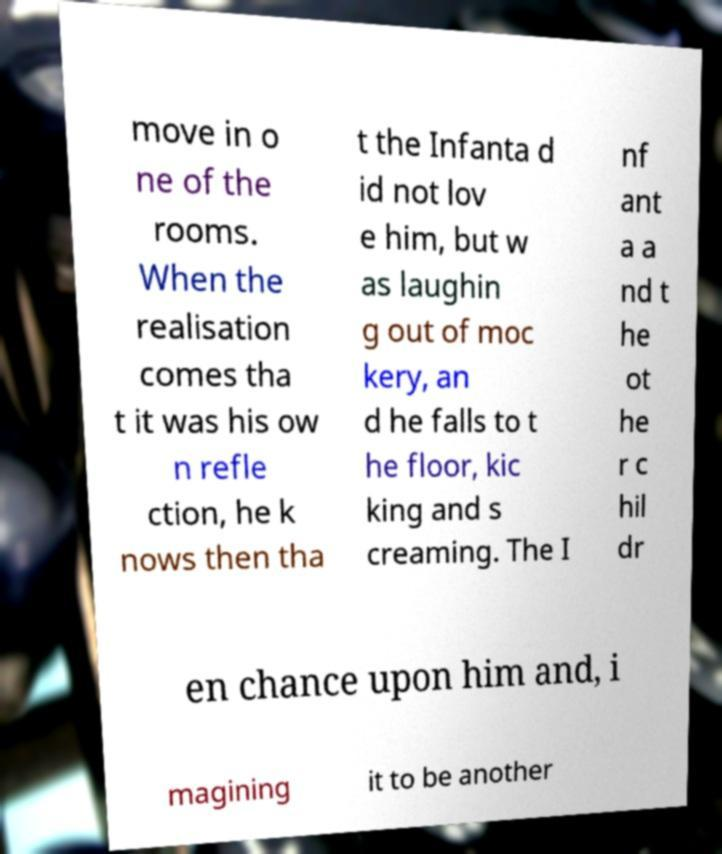Could you assist in decoding the text presented in this image and type it out clearly? move in o ne of the rooms. When the realisation comes tha t it was his ow n refle ction, he k nows then tha t the Infanta d id not lov e him, but w as laughin g out of moc kery, an d he falls to t he floor, kic king and s creaming. The I nf ant a a nd t he ot he r c hil dr en chance upon him and, i magining it to be another 